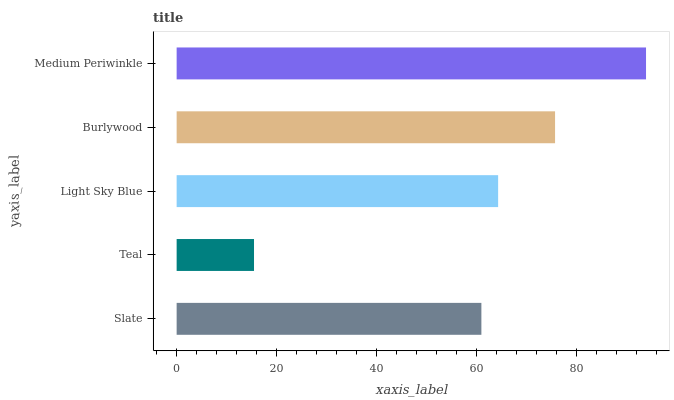Is Teal the minimum?
Answer yes or no. Yes. Is Medium Periwinkle the maximum?
Answer yes or no. Yes. Is Light Sky Blue the minimum?
Answer yes or no. No. Is Light Sky Blue the maximum?
Answer yes or no. No. Is Light Sky Blue greater than Teal?
Answer yes or no. Yes. Is Teal less than Light Sky Blue?
Answer yes or no. Yes. Is Teal greater than Light Sky Blue?
Answer yes or no. No. Is Light Sky Blue less than Teal?
Answer yes or no. No. Is Light Sky Blue the high median?
Answer yes or no. Yes. Is Light Sky Blue the low median?
Answer yes or no. Yes. Is Teal the high median?
Answer yes or no. No. Is Teal the low median?
Answer yes or no. No. 